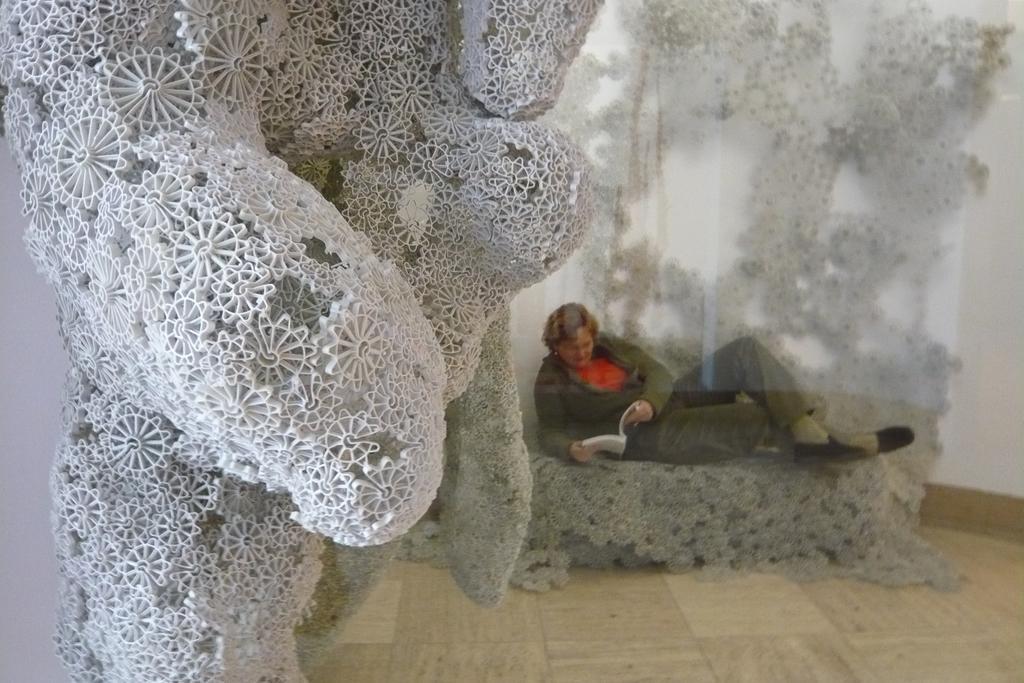Can you describe this image briefly? In the image we can see a sculpture. Behind the sculpture a man is sitting and holding a book. Behind him there is a wall. 